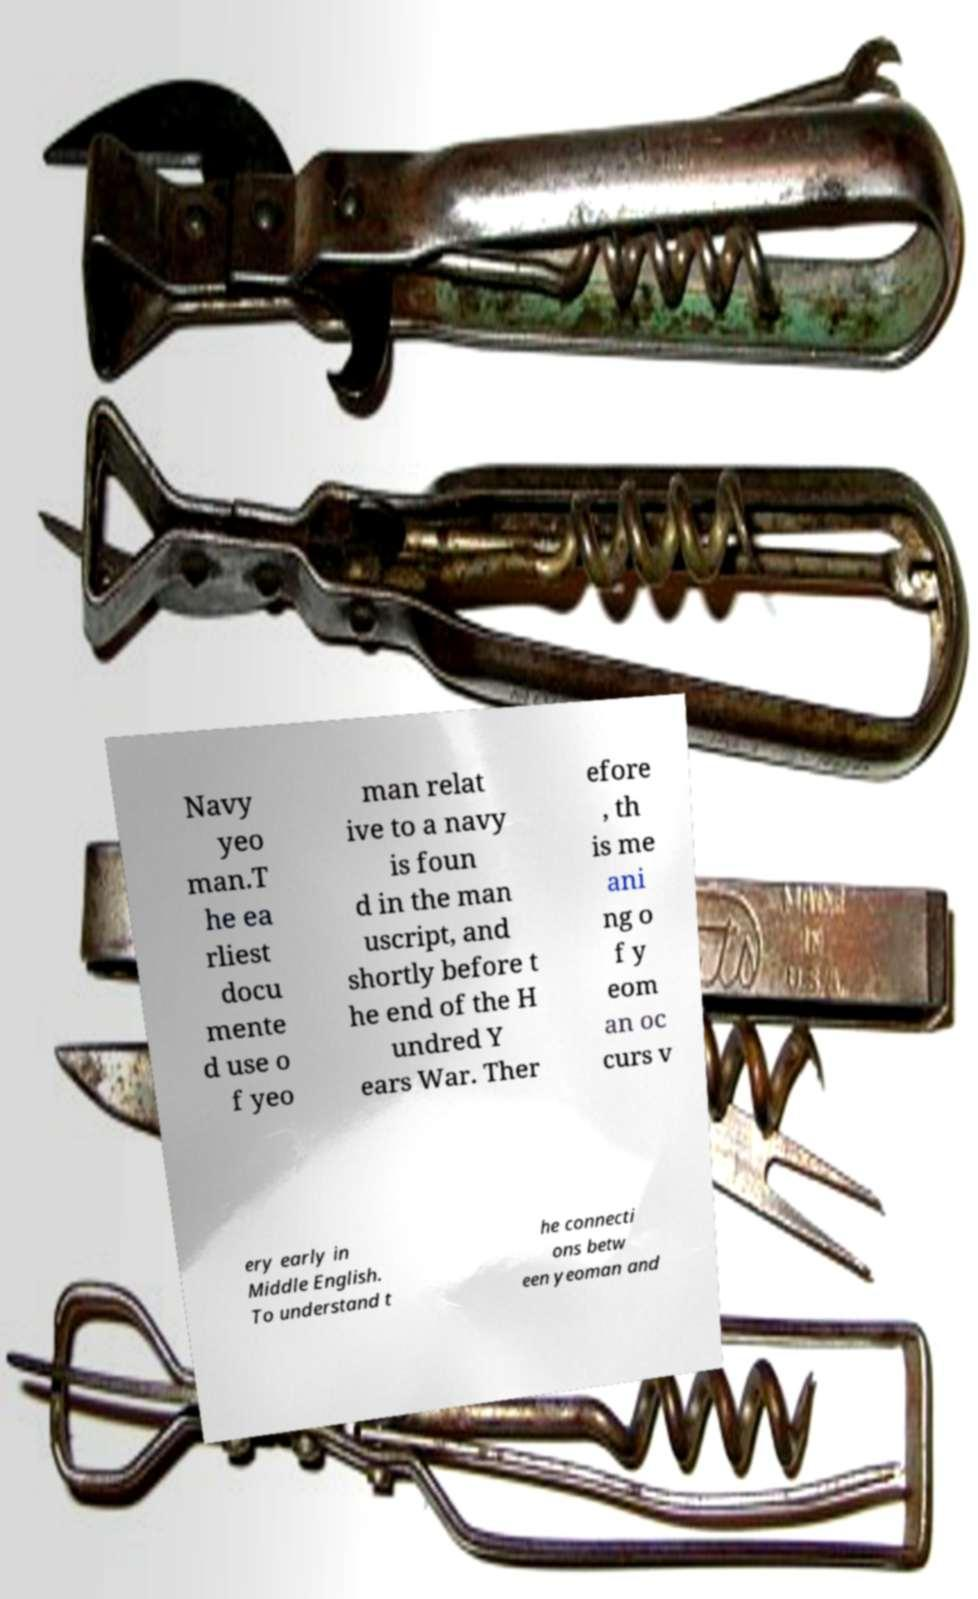Could you extract and type out the text from this image? Navy yeo man.T he ea rliest docu mente d use o f yeo man relat ive to a navy is foun d in the man uscript, and shortly before t he end of the H undred Y ears War. Ther efore , th is me ani ng o f y eom an oc curs v ery early in Middle English. To understand t he connecti ons betw een yeoman and 